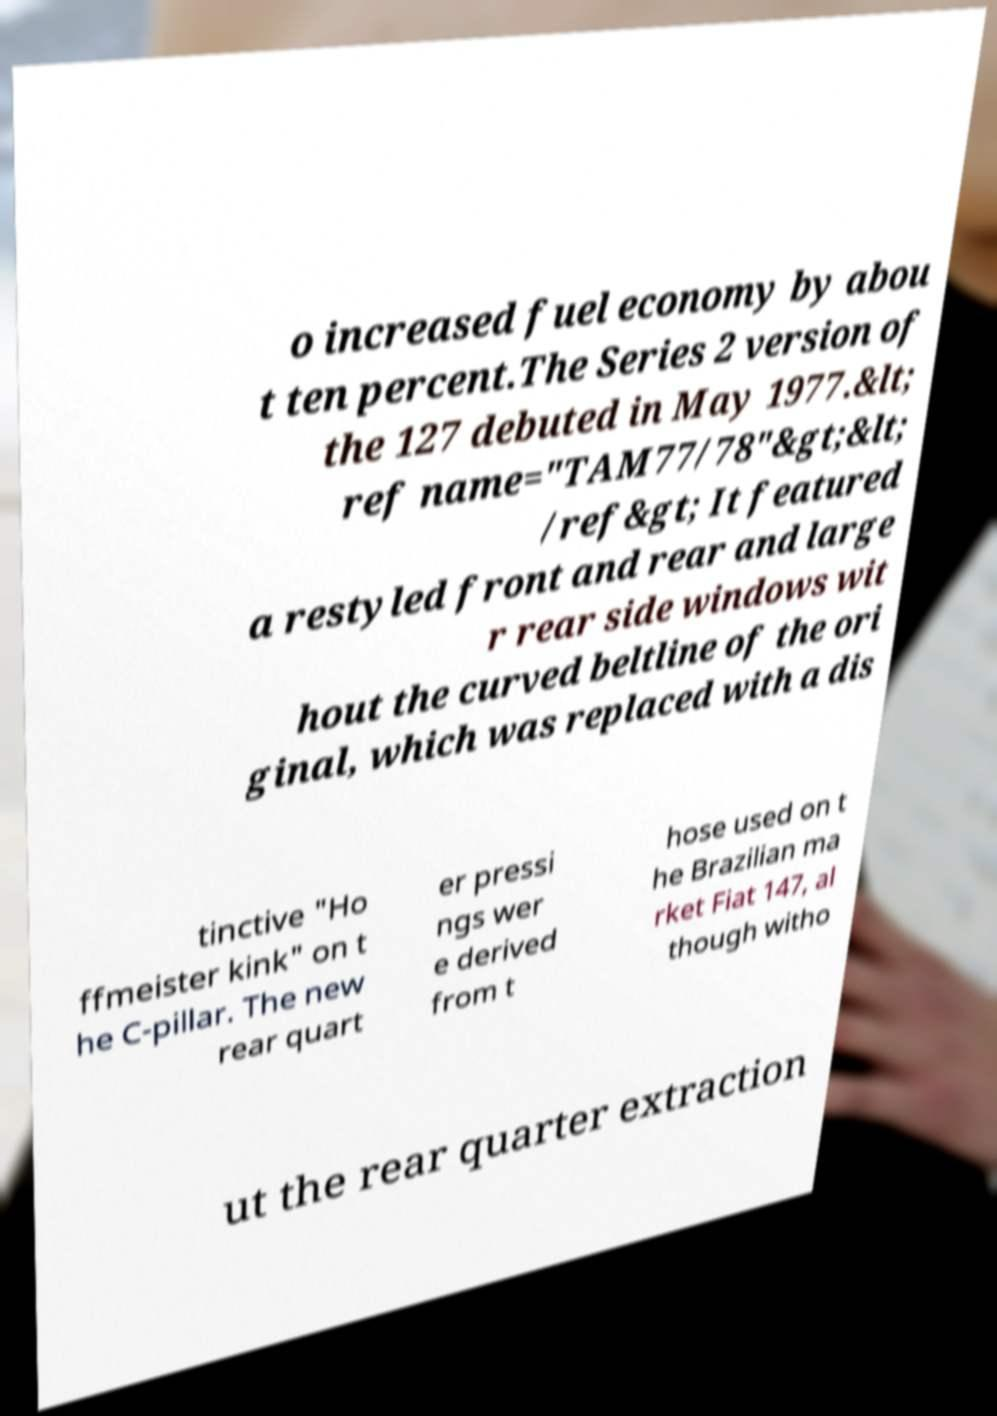What messages or text are displayed in this image? I need them in a readable, typed format. o increased fuel economy by abou t ten percent.The Series 2 version of the 127 debuted in May 1977.&lt; ref name="TAM77/78"&gt;&lt; /ref&gt; It featured a restyled front and rear and large r rear side windows wit hout the curved beltline of the ori ginal, which was replaced with a dis tinctive "Ho ffmeister kink" on t he C-pillar. The new rear quart er pressi ngs wer e derived from t hose used on t he Brazilian ma rket Fiat 147, al though witho ut the rear quarter extraction 